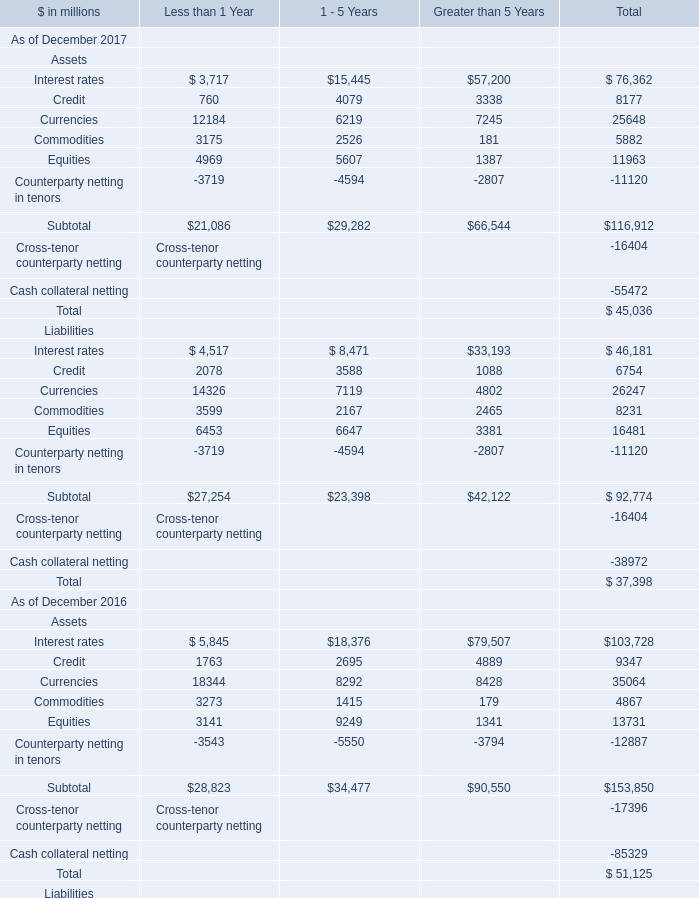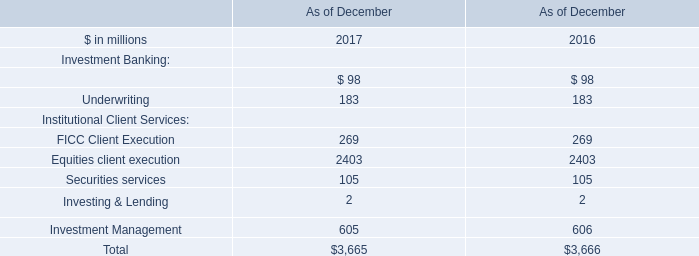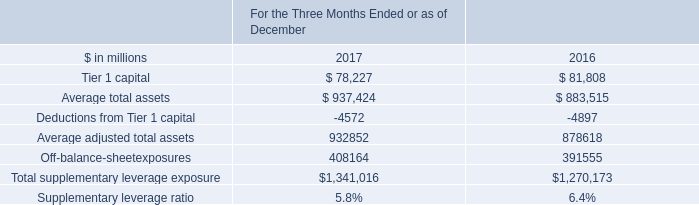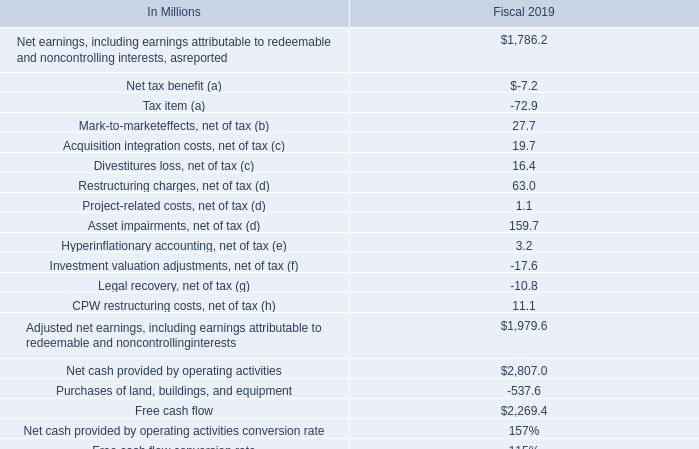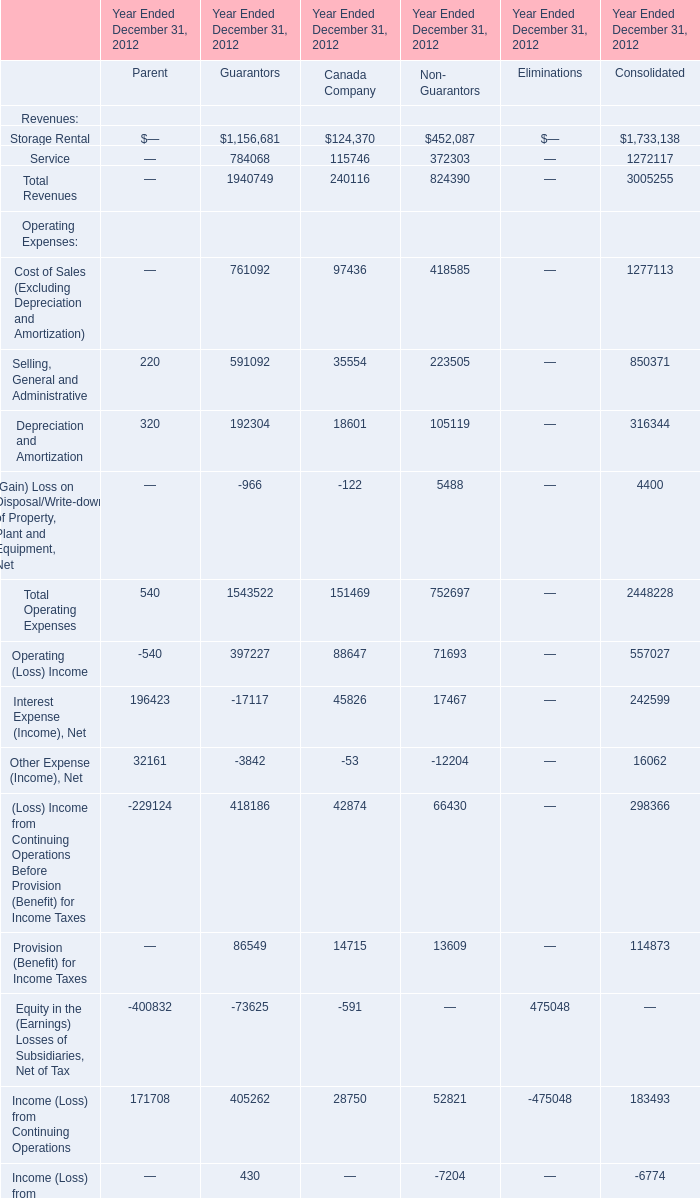What's the average of Service of Year Ended December 31, 2012 Guarantors, and Interest rates Liabilities of Less than 1 Year is ? 
Computations: ((784068.0 + 4517.0) / 2)
Answer: 394292.5. 